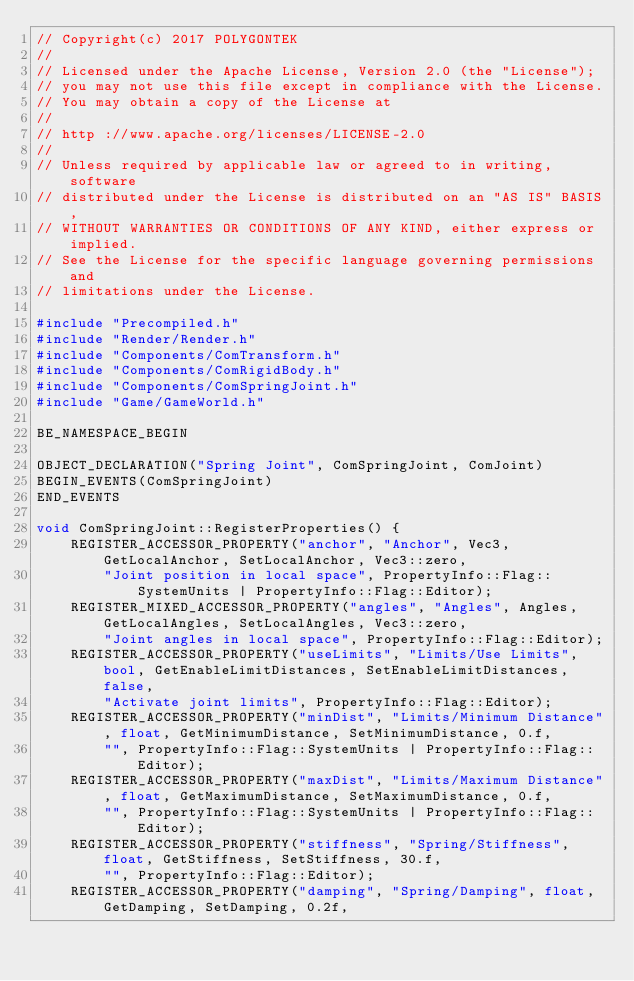Convert code to text. <code><loc_0><loc_0><loc_500><loc_500><_C++_>// Copyright(c) 2017 POLYGONTEK
// 
// Licensed under the Apache License, Version 2.0 (the "License");
// you may not use this file except in compliance with the License.
// You may obtain a copy of the License at
// 
// http ://www.apache.org/licenses/LICENSE-2.0
// 
// Unless required by applicable law or agreed to in writing, software
// distributed under the License is distributed on an "AS IS" BASIS,
// WITHOUT WARRANTIES OR CONDITIONS OF ANY KIND, either express or implied.
// See the License for the specific language governing permissions and
// limitations under the License.

#include "Precompiled.h"
#include "Render/Render.h"
#include "Components/ComTransform.h"
#include "Components/ComRigidBody.h"
#include "Components/ComSpringJoint.h"
#include "Game/GameWorld.h"

BE_NAMESPACE_BEGIN

OBJECT_DECLARATION("Spring Joint", ComSpringJoint, ComJoint)
BEGIN_EVENTS(ComSpringJoint)
END_EVENTS

void ComSpringJoint::RegisterProperties() {
    REGISTER_ACCESSOR_PROPERTY("anchor", "Anchor", Vec3, GetLocalAnchor, SetLocalAnchor, Vec3::zero, 
        "Joint position in local space", PropertyInfo::Flag::SystemUnits | PropertyInfo::Flag::Editor);
    REGISTER_MIXED_ACCESSOR_PROPERTY("angles", "Angles", Angles, GetLocalAngles, SetLocalAngles, Vec3::zero, 
        "Joint angles in local space", PropertyInfo::Flag::Editor);
    REGISTER_ACCESSOR_PROPERTY("useLimits", "Limits/Use Limits", bool, GetEnableLimitDistances, SetEnableLimitDistances, false, 
        "Activate joint limits", PropertyInfo::Flag::Editor);
    REGISTER_ACCESSOR_PROPERTY("minDist", "Limits/Minimum Distance", float, GetMinimumDistance, SetMinimumDistance, 0.f, 
        "", PropertyInfo::Flag::SystemUnits | PropertyInfo::Flag::Editor);
    REGISTER_ACCESSOR_PROPERTY("maxDist", "Limits/Maximum Distance", float, GetMaximumDistance, SetMaximumDistance, 0.f, 
        "", PropertyInfo::Flag::SystemUnits | PropertyInfo::Flag::Editor);
    REGISTER_ACCESSOR_PROPERTY("stiffness", "Spring/Stiffness", float, GetStiffness, SetStiffness, 30.f, 
        "", PropertyInfo::Flag::Editor);
    REGISTER_ACCESSOR_PROPERTY("damping", "Spring/Damping", float, GetDamping, SetDamping, 0.2f, </code> 